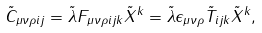Convert formula to latex. <formula><loc_0><loc_0><loc_500><loc_500>\tilde { C } _ { \mu \nu \rho i j } = \tilde { \lambda } F _ { \mu \nu \rho i j k } \tilde { X } ^ { k } = \tilde { \lambda } \epsilon _ { \mu \nu \rho } \tilde { T } _ { i j k } \tilde { X } ^ { k } ,</formula> 